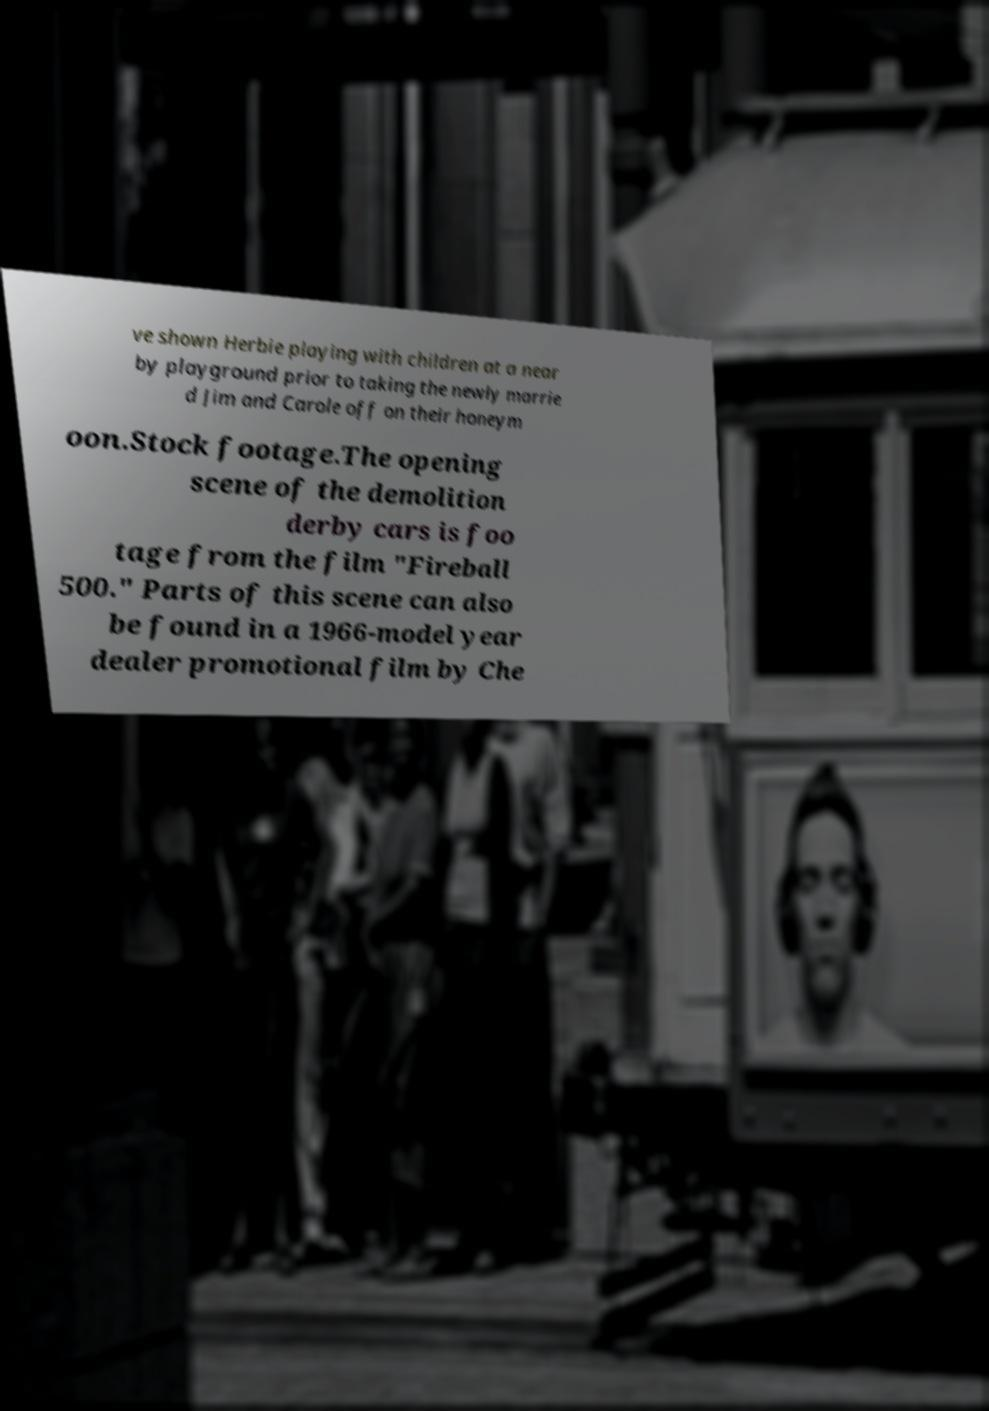Can you read and provide the text displayed in the image?This photo seems to have some interesting text. Can you extract and type it out for me? ve shown Herbie playing with children at a near by playground prior to taking the newly marrie d Jim and Carole off on their honeym oon.Stock footage.The opening scene of the demolition derby cars is foo tage from the film "Fireball 500." Parts of this scene can also be found in a 1966-model year dealer promotional film by Che 